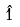<formula> <loc_0><loc_0><loc_500><loc_500>\hat { 1 }</formula> 